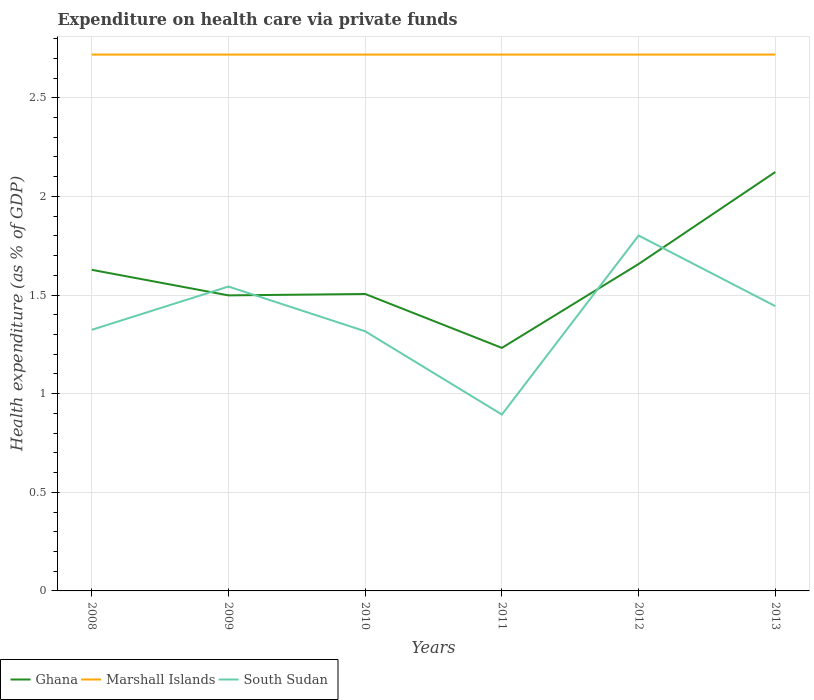How many different coloured lines are there?
Keep it short and to the point. 3. Does the line corresponding to South Sudan intersect with the line corresponding to Ghana?
Your answer should be compact. Yes. Across all years, what is the maximum expenditure made on health care in Ghana?
Keep it short and to the point. 1.23. What is the total expenditure made on health care in Marshall Islands in the graph?
Give a very brief answer. 1.5050814589745443e-5. What is the difference between the highest and the second highest expenditure made on health care in Marshall Islands?
Your response must be concise. 3.402636000027215e-5. How many lines are there?
Your response must be concise. 3. How many years are there in the graph?
Make the answer very short. 6. What is the difference between two consecutive major ticks on the Y-axis?
Give a very brief answer. 0.5. Are the values on the major ticks of Y-axis written in scientific E-notation?
Ensure brevity in your answer.  No. Does the graph contain grids?
Offer a terse response. Yes. How many legend labels are there?
Ensure brevity in your answer.  3. What is the title of the graph?
Offer a very short reply. Expenditure on health care via private funds. Does "High income" appear as one of the legend labels in the graph?
Ensure brevity in your answer.  No. What is the label or title of the Y-axis?
Your response must be concise. Health expenditure (as % of GDP). What is the Health expenditure (as % of GDP) of Ghana in 2008?
Provide a succinct answer. 1.63. What is the Health expenditure (as % of GDP) in Marshall Islands in 2008?
Your response must be concise. 2.72. What is the Health expenditure (as % of GDP) of South Sudan in 2008?
Provide a short and direct response. 1.32. What is the Health expenditure (as % of GDP) in Ghana in 2009?
Your answer should be very brief. 1.5. What is the Health expenditure (as % of GDP) of Marshall Islands in 2009?
Give a very brief answer. 2.72. What is the Health expenditure (as % of GDP) of South Sudan in 2009?
Offer a terse response. 1.54. What is the Health expenditure (as % of GDP) of Ghana in 2010?
Keep it short and to the point. 1.51. What is the Health expenditure (as % of GDP) in Marshall Islands in 2010?
Your answer should be very brief. 2.72. What is the Health expenditure (as % of GDP) of South Sudan in 2010?
Give a very brief answer. 1.32. What is the Health expenditure (as % of GDP) of Ghana in 2011?
Your answer should be compact. 1.23. What is the Health expenditure (as % of GDP) of Marshall Islands in 2011?
Keep it short and to the point. 2.72. What is the Health expenditure (as % of GDP) in South Sudan in 2011?
Ensure brevity in your answer.  0.89. What is the Health expenditure (as % of GDP) in Ghana in 2012?
Your answer should be very brief. 1.66. What is the Health expenditure (as % of GDP) in Marshall Islands in 2012?
Offer a terse response. 2.72. What is the Health expenditure (as % of GDP) of South Sudan in 2012?
Ensure brevity in your answer.  1.8. What is the Health expenditure (as % of GDP) in Ghana in 2013?
Your response must be concise. 2.12. What is the Health expenditure (as % of GDP) of Marshall Islands in 2013?
Keep it short and to the point. 2.72. What is the Health expenditure (as % of GDP) of South Sudan in 2013?
Offer a terse response. 1.44. Across all years, what is the maximum Health expenditure (as % of GDP) of Ghana?
Your answer should be very brief. 2.12. Across all years, what is the maximum Health expenditure (as % of GDP) in Marshall Islands?
Provide a succinct answer. 2.72. Across all years, what is the maximum Health expenditure (as % of GDP) of South Sudan?
Make the answer very short. 1.8. Across all years, what is the minimum Health expenditure (as % of GDP) of Ghana?
Ensure brevity in your answer.  1.23. Across all years, what is the minimum Health expenditure (as % of GDP) of Marshall Islands?
Offer a terse response. 2.72. Across all years, what is the minimum Health expenditure (as % of GDP) in South Sudan?
Make the answer very short. 0.89. What is the total Health expenditure (as % of GDP) of Ghana in the graph?
Provide a succinct answer. 9.64. What is the total Health expenditure (as % of GDP) in Marshall Islands in the graph?
Give a very brief answer. 16.31. What is the total Health expenditure (as % of GDP) in South Sudan in the graph?
Make the answer very short. 8.32. What is the difference between the Health expenditure (as % of GDP) of Ghana in 2008 and that in 2009?
Give a very brief answer. 0.13. What is the difference between the Health expenditure (as % of GDP) of Marshall Islands in 2008 and that in 2009?
Keep it short and to the point. -0. What is the difference between the Health expenditure (as % of GDP) in South Sudan in 2008 and that in 2009?
Provide a short and direct response. -0.22. What is the difference between the Health expenditure (as % of GDP) in Ghana in 2008 and that in 2010?
Your answer should be compact. 0.12. What is the difference between the Health expenditure (as % of GDP) in South Sudan in 2008 and that in 2010?
Provide a short and direct response. 0.01. What is the difference between the Health expenditure (as % of GDP) in Ghana in 2008 and that in 2011?
Your answer should be compact. 0.4. What is the difference between the Health expenditure (as % of GDP) of South Sudan in 2008 and that in 2011?
Ensure brevity in your answer.  0.43. What is the difference between the Health expenditure (as % of GDP) of Ghana in 2008 and that in 2012?
Provide a short and direct response. -0.03. What is the difference between the Health expenditure (as % of GDP) of South Sudan in 2008 and that in 2012?
Provide a succinct answer. -0.48. What is the difference between the Health expenditure (as % of GDP) of Ghana in 2008 and that in 2013?
Keep it short and to the point. -0.5. What is the difference between the Health expenditure (as % of GDP) in South Sudan in 2008 and that in 2013?
Make the answer very short. -0.12. What is the difference between the Health expenditure (as % of GDP) of Ghana in 2009 and that in 2010?
Provide a short and direct response. -0.01. What is the difference between the Health expenditure (as % of GDP) of Marshall Islands in 2009 and that in 2010?
Provide a succinct answer. -0. What is the difference between the Health expenditure (as % of GDP) in South Sudan in 2009 and that in 2010?
Your answer should be compact. 0.23. What is the difference between the Health expenditure (as % of GDP) of Ghana in 2009 and that in 2011?
Offer a terse response. 0.27. What is the difference between the Health expenditure (as % of GDP) in Marshall Islands in 2009 and that in 2011?
Offer a very short reply. 0. What is the difference between the Health expenditure (as % of GDP) in South Sudan in 2009 and that in 2011?
Offer a very short reply. 0.65. What is the difference between the Health expenditure (as % of GDP) in Ghana in 2009 and that in 2012?
Provide a succinct answer. -0.16. What is the difference between the Health expenditure (as % of GDP) in Marshall Islands in 2009 and that in 2012?
Give a very brief answer. 0. What is the difference between the Health expenditure (as % of GDP) in South Sudan in 2009 and that in 2012?
Your response must be concise. -0.26. What is the difference between the Health expenditure (as % of GDP) in Ghana in 2009 and that in 2013?
Keep it short and to the point. -0.63. What is the difference between the Health expenditure (as % of GDP) of South Sudan in 2009 and that in 2013?
Your answer should be compact. 0.1. What is the difference between the Health expenditure (as % of GDP) of Ghana in 2010 and that in 2011?
Give a very brief answer. 0.27. What is the difference between the Health expenditure (as % of GDP) in South Sudan in 2010 and that in 2011?
Your answer should be very brief. 0.42. What is the difference between the Health expenditure (as % of GDP) in Ghana in 2010 and that in 2012?
Provide a succinct answer. -0.15. What is the difference between the Health expenditure (as % of GDP) in Marshall Islands in 2010 and that in 2012?
Offer a terse response. 0. What is the difference between the Health expenditure (as % of GDP) of South Sudan in 2010 and that in 2012?
Provide a succinct answer. -0.49. What is the difference between the Health expenditure (as % of GDP) in Ghana in 2010 and that in 2013?
Your response must be concise. -0.62. What is the difference between the Health expenditure (as % of GDP) in South Sudan in 2010 and that in 2013?
Make the answer very short. -0.13. What is the difference between the Health expenditure (as % of GDP) of Ghana in 2011 and that in 2012?
Your response must be concise. -0.43. What is the difference between the Health expenditure (as % of GDP) in Marshall Islands in 2011 and that in 2012?
Your answer should be very brief. 0. What is the difference between the Health expenditure (as % of GDP) in South Sudan in 2011 and that in 2012?
Offer a very short reply. -0.91. What is the difference between the Health expenditure (as % of GDP) of Ghana in 2011 and that in 2013?
Offer a terse response. -0.89. What is the difference between the Health expenditure (as % of GDP) in South Sudan in 2011 and that in 2013?
Your response must be concise. -0.55. What is the difference between the Health expenditure (as % of GDP) in Ghana in 2012 and that in 2013?
Ensure brevity in your answer.  -0.47. What is the difference between the Health expenditure (as % of GDP) in South Sudan in 2012 and that in 2013?
Provide a short and direct response. 0.36. What is the difference between the Health expenditure (as % of GDP) in Ghana in 2008 and the Health expenditure (as % of GDP) in Marshall Islands in 2009?
Make the answer very short. -1.09. What is the difference between the Health expenditure (as % of GDP) of Ghana in 2008 and the Health expenditure (as % of GDP) of South Sudan in 2009?
Make the answer very short. 0.08. What is the difference between the Health expenditure (as % of GDP) of Marshall Islands in 2008 and the Health expenditure (as % of GDP) of South Sudan in 2009?
Offer a terse response. 1.18. What is the difference between the Health expenditure (as % of GDP) of Ghana in 2008 and the Health expenditure (as % of GDP) of Marshall Islands in 2010?
Offer a terse response. -1.09. What is the difference between the Health expenditure (as % of GDP) in Ghana in 2008 and the Health expenditure (as % of GDP) in South Sudan in 2010?
Make the answer very short. 0.31. What is the difference between the Health expenditure (as % of GDP) of Marshall Islands in 2008 and the Health expenditure (as % of GDP) of South Sudan in 2010?
Offer a terse response. 1.4. What is the difference between the Health expenditure (as % of GDP) in Ghana in 2008 and the Health expenditure (as % of GDP) in Marshall Islands in 2011?
Keep it short and to the point. -1.09. What is the difference between the Health expenditure (as % of GDP) of Ghana in 2008 and the Health expenditure (as % of GDP) of South Sudan in 2011?
Offer a very short reply. 0.73. What is the difference between the Health expenditure (as % of GDP) in Marshall Islands in 2008 and the Health expenditure (as % of GDP) in South Sudan in 2011?
Your response must be concise. 1.82. What is the difference between the Health expenditure (as % of GDP) of Ghana in 2008 and the Health expenditure (as % of GDP) of Marshall Islands in 2012?
Make the answer very short. -1.09. What is the difference between the Health expenditure (as % of GDP) in Ghana in 2008 and the Health expenditure (as % of GDP) in South Sudan in 2012?
Ensure brevity in your answer.  -0.17. What is the difference between the Health expenditure (as % of GDP) of Marshall Islands in 2008 and the Health expenditure (as % of GDP) of South Sudan in 2012?
Keep it short and to the point. 0.92. What is the difference between the Health expenditure (as % of GDP) of Ghana in 2008 and the Health expenditure (as % of GDP) of Marshall Islands in 2013?
Offer a terse response. -1.09. What is the difference between the Health expenditure (as % of GDP) in Ghana in 2008 and the Health expenditure (as % of GDP) in South Sudan in 2013?
Provide a succinct answer. 0.18. What is the difference between the Health expenditure (as % of GDP) in Marshall Islands in 2008 and the Health expenditure (as % of GDP) in South Sudan in 2013?
Your response must be concise. 1.28. What is the difference between the Health expenditure (as % of GDP) of Ghana in 2009 and the Health expenditure (as % of GDP) of Marshall Islands in 2010?
Provide a succinct answer. -1.22. What is the difference between the Health expenditure (as % of GDP) of Ghana in 2009 and the Health expenditure (as % of GDP) of South Sudan in 2010?
Give a very brief answer. 0.18. What is the difference between the Health expenditure (as % of GDP) of Marshall Islands in 2009 and the Health expenditure (as % of GDP) of South Sudan in 2010?
Provide a succinct answer. 1.4. What is the difference between the Health expenditure (as % of GDP) in Ghana in 2009 and the Health expenditure (as % of GDP) in Marshall Islands in 2011?
Make the answer very short. -1.22. What is the difference between the Health expenditure (as % of GDP) of Ghana in 2009 and the Health expenditure (as % of GDP) of South Sudan in 2011?
Your response must be concise. 0.6. What is the difference between the Health expenditure (as % of GDP) of Marshall Islands in 2009 and the Health expenditure (as % of GDP) of South Sudan in 2011?
Keep it short and to the point. 1.82. What is the difference between the Health expenditure (as % of GDP) of Ghana in 2009 and the Health expenditure (as % of GDP) of Marshall Islands in 2012?
Provide a succinct answer. -1.22. What is the difference between the Health expenditure (as % of GDP) of Ghana in 2009 and the Health expenditure (as % of GDP) of South Sudan in 2012?
Your answer should be compact. -0.3. What is the difference between the Health expenditure (as % of GDP) of Marshall Islands in 2009 and the Health expenditure (as % of GDP) of South Sudan in 2012?
Give a very brief answer. 0.92. What is the difference between the Health expenditure (as % of GDP) in Ghana in 2009 and the Health expenditure (as % of GDP) in Marshall Islands in 2013?
Offer a very short reply. -1.22. What is the difference between the Health expenditure (as % of GDP) of Ghana in 2009 and the Health expenditure (as % of GDP) of South Sudan in 2013?
Keep it short and to the point. 0.05. What is the difference between the Health expenditure (as % of GDP) in Marshall Islands in 2009 and the Health expenditure (as % of GDP) in South Sudan in 2013?
Make the answer very short. 1.28. What is the difference between the Health expenditure (as % of GDP) of Ghana in 2010 and the Health expenditure (as % of GDP) of Marshall Islands in 2011?
Keep it short and to the point. -1.21. What is the difference between the Health expenditure (as % of GDP) of Ghana in 2010 and the Health expenditure (as % of GDP) of South Sudan in 2011?
Offer a very short reply. 0.61. What is the difference between the Health expenditure (as % of GDP) in Marshall Islands in 2010 and the Health expenditure (as % of GDP) in South Sudan in 2011?
Your response must be concise. 1.82. What is the difference between the Health expenditure (as % of GDP) of Ghana in 2010 and the Health expenditure (as % of GDP) of Marshall Islands in 2012?
Your response must be concise. -1.21. What is the difference between the Health expenditure (as % of GDP) in Ghana in 2010 and the Health expenditure (as % of GDP) in South Sudan in 2012?
Your answer should be compact. -0.3. What is the difference between the Health expenditure (as % of GDP) in Marshall Islands in 2010 and the Health expenditure (as % of GDP) in South Sudan in 2012?
Offer a very short reply. 0.92. What is the difference between the Health expenditure (as % of GDP) in Ghana in 2010 and the Health expenditure (as % of GDP) in Marshall Islands in 2013?
Ensure brevity in your answer.  -1.21. What is the difference between the Health expenditure (as % of GDP) of Ghana in 2010 and the Health expenditure (as % of GDP) of South Sudan in 2013?
Offer a terse response. 0.06. What is the difference between the Health expenditure (as % of GDP) of Marshall Islands in 2010 and the Health expenditure (as % of GDP) of South Sudan in 2013?
Keep it short and to the point. 1.28. What is the difference between the Health expenditure (as % of GDP) in Ghana in 2011 and the Health expenditure (as % of GDP) in Marshall Islands in 2012?
Your answer should be very brief. -1.49. What is the difference between the Health expenditure (as % of GDP) of Ghana in 2011 and the Health expenditure (as % of GDP) of South Sudan in 2012?
Offer a very short reply. -0.57. What is the difference between the Health expenditure (as % of GDP) in Marshall Islands in 2011 and the Health expenditure (as % of GDP) in South Sudan in 2012?
Your response must be concise. 0.92. What is the difference between the Health expenditure (as % of GDP) in Ghana in 2011 and the Health expenditure (as % of GDP) in Marshall Islands in 2013?
Provide a short and direct response. -1.49. What is the difference between the Health expenditure (as % of GDP) in Ghana in 2011 and the Health expenditure (as % of GDP) in South Sudan in 2013?
Ensure brevity in your answer.  -0.21. What is the difference between the Health expenditure (as % of GDP) in Marshall Islands in 2011 and the Health expenditure (as % of GDP) in South Sudan in 2013?
Your answer should be very brief. 1.28. What is the difference between the Health expenditure (as % of GDP) of Ghana in 2012 and the Health expenditure (as % of GDP) of Marshall Islands in 2013?
Make the answer very short. -1.06. What is the difference between the Health expenditure (as % of GDP) of Ghana in 2012 and the Health expenditure (as % of GDP) of South Sudan in 2013?
Offer a terse response. 0.21. What is the difference between the Health expenditure (as % of GDP) of Marshall Islands in 2012 and the Health expenditure (as % of GDP) of South Sudan in 2013?
Your answer should be very brief. 1.28. What is the average Health expenditure (as % of GDP) in Ghana per year?
Offer a terse response. 1.61. What is the average Health expenditure (as % of GDP) in Marshall Islands per year?
Offer a terse response. 2.72. What is the average Health expenditure (as % of GDP) of South Sudan per year?
Provide a succinct answer. 1.39. In the year 2008, what is the difference between the Health expenditure (as % of GDP) in Ghana and Health expenditure (as % of GDP) in Marshall Islands?
Offer a terse response. -1.09. In the year 2008, what is the difference between the Health expenditure (as % of GDP) of Ghana and Health expenditure (as % of GDP) of South Sudan?
Keep it short and to the point. 0.3. In the year 2008, what is the difference between the Health expenditure (as % of GDP) in Marshall Islands and Health expenditure (as % of GDP) in South Sudan?
Your answer should be very brief. 1.4. In the year 2009, what is the difference between the Health expenditure (as % of GDP) of Ghana and Health expenditure (as % of GDP) of Marshall Islands?
Make the answer very short. -1.22. In the year 2009, what is the difference between the Health expenditure (as % of GDP) in Ghana and Health expenditure (as % of GDP) in South Sudan?
Offer a very short reply. -0.04. In the year 2009, what is the difference between the Health expenditure (as % of GDP) in Marshall Islands and Health expenditure (as % of GDP) in South Sudan?
Your answer should be very brief. 1.18. In the year 2010, what is the difference between the Health expenditure (as % of GDP) in Ghana and Health expenditure (as % of GDP) in Marshall Islands?
Your answer should be compact. -1.21. In the year 2010, what is the difference between the Health expenditure (as % of GDP) in Ghana and Health expenditure (as % of GDP) in South Sudan?
Offer a terse response. 0.19. In the year 2010, what is the difference between the Health expenditure (as % of GDP) in Marshall Islands and Health expenditure (as % of GDP) in South Sudan?
Offer a very short reply. 1.4. In the year 2011, what is the difference between the Health expenditure (as % of GDP) in Ghana and Health expenditure (as % of GDP) in Marshall Islands?
Ensure brevity in your answer.  -1.49. In the year 2011, what is the difference between the Health expenditure (as % of GDP) of Ghana and Health expenditure (as % of GDP) of South Sudan?
Your answer should be compact. 0.34. In the year 2011, what is the difference between the Health expenditure (as % of GDP) in Marshall Islands and Health expenditure (as % of GDP) in South Sudan?
Ensure brevity in your answer.  1.82. In the year 2012, what is the difference between the Health expenditure (as % of GDP) of Ghana and Health expenditure (as % of GDP) of Marshall Islands?
Your answer should be compact. -1.06. In the year 2012, what is the difference between the Health expenditure (as % of GDP) of Ghana and Health expenditure (as % of GDP) of South Sudan?
Your response must be concise. -0.14. In the year 2012, what is the difference between the Health expenditure (as % of GDP) of Marshall Islands and Health expenditure (as % of GDP) of South Sudan?
Your answer should be compact. 0.92. In the year 2013, what is the difference between the Health expenditure (as % of GDP) in Ghana and Health expenditure (as % of GDP) in Marshall Islands?
Offer a very short reply. -0.6. In the year 2013, what is the difference between the Health expenditure (as % of GDP) of Ghana and Health expenditure (as % of GDP) of South Sudan?
Make the answer very short. 0.68. In the year 2013, what is the difference between the Health expenditure (as % of GDP) in Marshall Islands and Health expenditure (as % of GDP) in South Sudan?
Keep it short and to the point. 1.28. What is the ratio of the Health expenditure (as % of GDP) in Ghana in 2008 to that in 2009?
Offer a very short reply. 1.09. What is the ratio of the Health expenditure (as % of GDP) of South Sudan in 2008 to that in 2009?
Your response must be concise. 0.86. What is the ratio of the Health expenditure (as % of GDP) of Ghana in 2008 to that in 2010?
Your answer should be compact. 1.08. What is the ratio of the Health expenditure (as % of GDP) of Ghana in 2008 to that in 2011?
Keep it short and to the point. 1.32. What is the ratio of the Health expenditure (as % of GDP) in Marshall Islands in 2008 to that in 2011?
Give a very brief answer. 1. What is the ratio of the Health expenditure (as % of GDP) in South Sudan in 2008 to that in 2011?
Your answer should be very brief. 1.48. What is the ratio of the Health expenditure (as % of GDP) of Ghana in 2008 to that in 2012?
Make the answer very short. 0.98. What is the ratio of the Health expenditure (as % of GDP) in South Sudan in 2008 to that in 2012?
Your answer should be very brief. 0.73. What is the ratio of the Health expenditure (as % of GDP) in Ghana in 2008 to that in 2013?
Your answer should be compact. 0.77. What is the ratio of the Health expenditure (as % of GDP) in South Sudan in 2008 to that in 2013?
Your answer should be very brief. 0.92. What is the ratio of the Health expenditure (as % of GDP) in Ghana in 2009 to that in 2010?
Offer a very short reply. 1. What is the ratio of the Health expenditure (as % of GDP) of Marshall Islands in 2009 to that in 2010?
Provide a succinct answer. 1. What is the ratio of the Health expenditure (as % of GDP) of South Sudan in 2009 to that in 2010?
Your response must be concise. 1.17. What is the ratio of the Health expenditure (as % of GDP) in Ghana in 2009 to that in 2011?
Provide a succinct answer. 1.22. What is the ratio of the Health expenditure (as % of GDP) of Marshall Islands in 2009 to that in 2011?
Give a very brief answer. 1. What is the ratio of the Health expenditure (as % of GDP) of South Sudan in 2009 to that in 2011?
Offer a terse response. 1.73. What is the ratio of the Health expenditure (as % of GDP) of Ghana in 2009 to that in 2012?
Offer a terse response. 0.9. What is the ratio of the Health expenditure (as % of GDP) in South Sudan in 2009 to that in 2012?
Make the answer very short. 0.86. What is the ratio of the Health expenditure (as % of GDP) of Ghana in 2009 to that in 2013?
Your response must be concise. 0.71. What is the ratio of the Health expenditure (as % of GDP) of Marshall Islands in 2009 to that in 2013?
Provide a short and direct response. 1. What is the ratio of the Health expenditure (as % of GDP) in South Sudan in 2009 to that in 2013?
Provide a succinct answer. 1.07. What is the ratio of the Health expenditure (as % of GDP) of Ghana in 2010 to that in 2011?
Ensure brevity in your answer.  1.22. What is the ratio of the Health expenditure (as % of GDP) in South Sudan in 2010 to that in 2011?
Your answer should be compact. 1.47. What is the ratio of the Health expenditure (as % of GDP) in Ghana in 2010 to that in 2012?
Offer a terse response. 0.91. What is the ratio of the Health expenditure (as % of GDP) in South Sudan in 2010 to that in 2012?
Offer a very short reply. 0.73. What is the ratio of the Health expenditure (as % of GDP) of Ghana in 2010 to that in 2013?
Give a very brief answer. 0.71. What is the ratio of the Health expenditure (as % of GDP) in Marshall Islands in 2010 to that in 2013?
Your answer should be very brief. 1. What is the ratio of the Health expenditure (as % of GDP) in South Sudan in 2010 to that in 2013?
Make the answer very short. 0.91. What is the ratio of the Health expenditure (as % of GDP) in Ghana in 2011 to that in 2012?
Provide a succinct answer. 0.74. What is the ratio of the Health expenditure (as % of GDP) of Marshall Islands in 2011 to that in 2012?
Provide a short and direct response. 1. What is the ratio of the Health expenditure (as % of GDP) of South Sudan in 2011 to that in 2012?
Make the answer very short. 0.5. What is the ratio of the Health expenditure (as % of GDP) in Ghana in 2011 to that in 2013?
Offer a terse response. 0.58. What is the ratio of the Health expenditure (as % of GDP) of Marshall Islands in 2011 to that in 2013?
Offer a very short reply. 1. What is the ratio of the Health expenditure (as % of GDP) in South Sudan in 2011 to that in 2013?
Offer a terse response. 0.62. What is the ratio of the Health expenditure (as % of GDP) of Ghana in 2012 to that in 2013?
Give a very brief answer. 0.78. What is the ratio of the Health expenditure (as % of GDP) of Marshall Islands in 2012 to that in 2013?
Your answer should be very brief. 1. What is the ratio of the Health expenditure (as % of GDP) in South Sudan in 2012 to that in 2013?
Your answer should be compact. 1.25. What is the difference between the highest and the second highest Health expenditure (as % of GDP) in Ghana?
Ensure brevity in your answer.  0.47. What is the difference between the highest and the second highest Health expenditure (as % of GDP) of Marshall Islands?
Offer a very short reply. 0. What is the difference between the highest and the second highest Health expenditure (as % of GDP) in South Sudan?
Offer a terse response. 0.26. What is the difference between the highest and the lowest Health expenditure (as % of GDP) of Ghana?
Make the answer very short. 0.89. What is the difference between the highest and the lowest Health expenditure (as % of GDP) of Marshall Islands?
Provide a succinct answer. 0. What is the difference between the highest and the lowest Health expenditure (as % of GDP) in South Sudan?
Your answer should be compact. 0.91. 